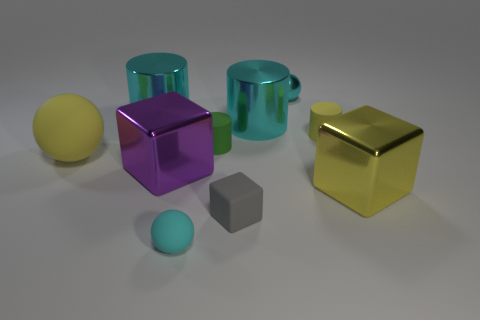The rubber ball behind the matte block is what color?
Provide a short and direct response. Yellow. Are there more gray cubes that are behind the purple object than yellow cubes?
Make the answer very short. No. There is a cyan thing to the left of the small cyan rubber ball; is its shape the same as the tiny metallic thing?
Your response must be concise. No. What number of red things are either blocks or large metallic cubes?
Give a very brief answer. 0. Is the number of metallic blocks greater than the number of purple blocks?
Provide a succinct answer. Yes. What is the color of the shiny object that is the same size as the rubber block?
Your answer should be compact. Cyan. What number of cylinders are either cyan metal things or green things?
Your response must be concise. 3. Is the shape of the small green matte object the same as the big cyan object that is left of the tiny cyan matte thing?
Your response must be concise. Yes. How many objects are the same size as the yellow matte cylinder?
Provide a short and direct response. 4. Do the large yellow thing that is left of the yellow shiny block and the purple thing behind the tiny gray matte block have the same shape?
Ensure brevity in your answer.  No. 